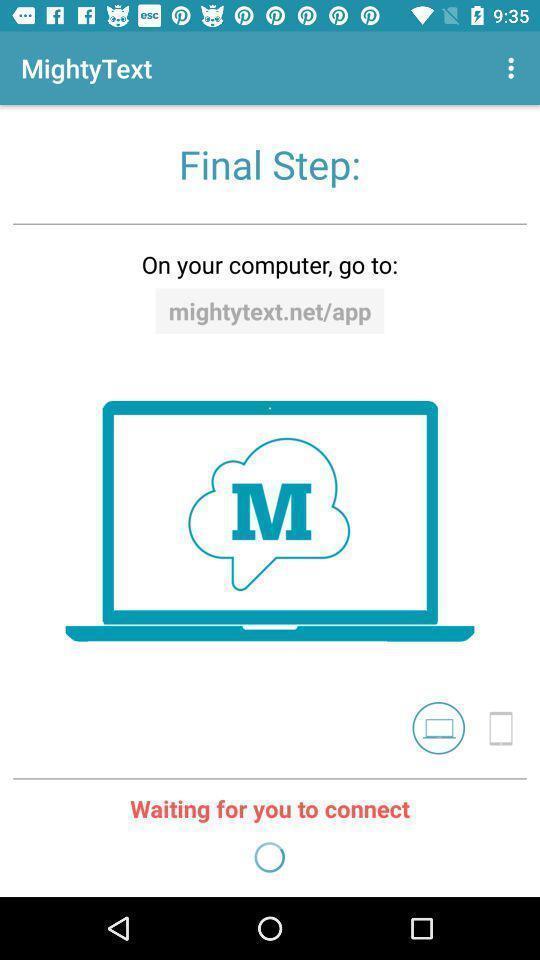Describe the key features of this screenshot. Welcome page of a texting application. 